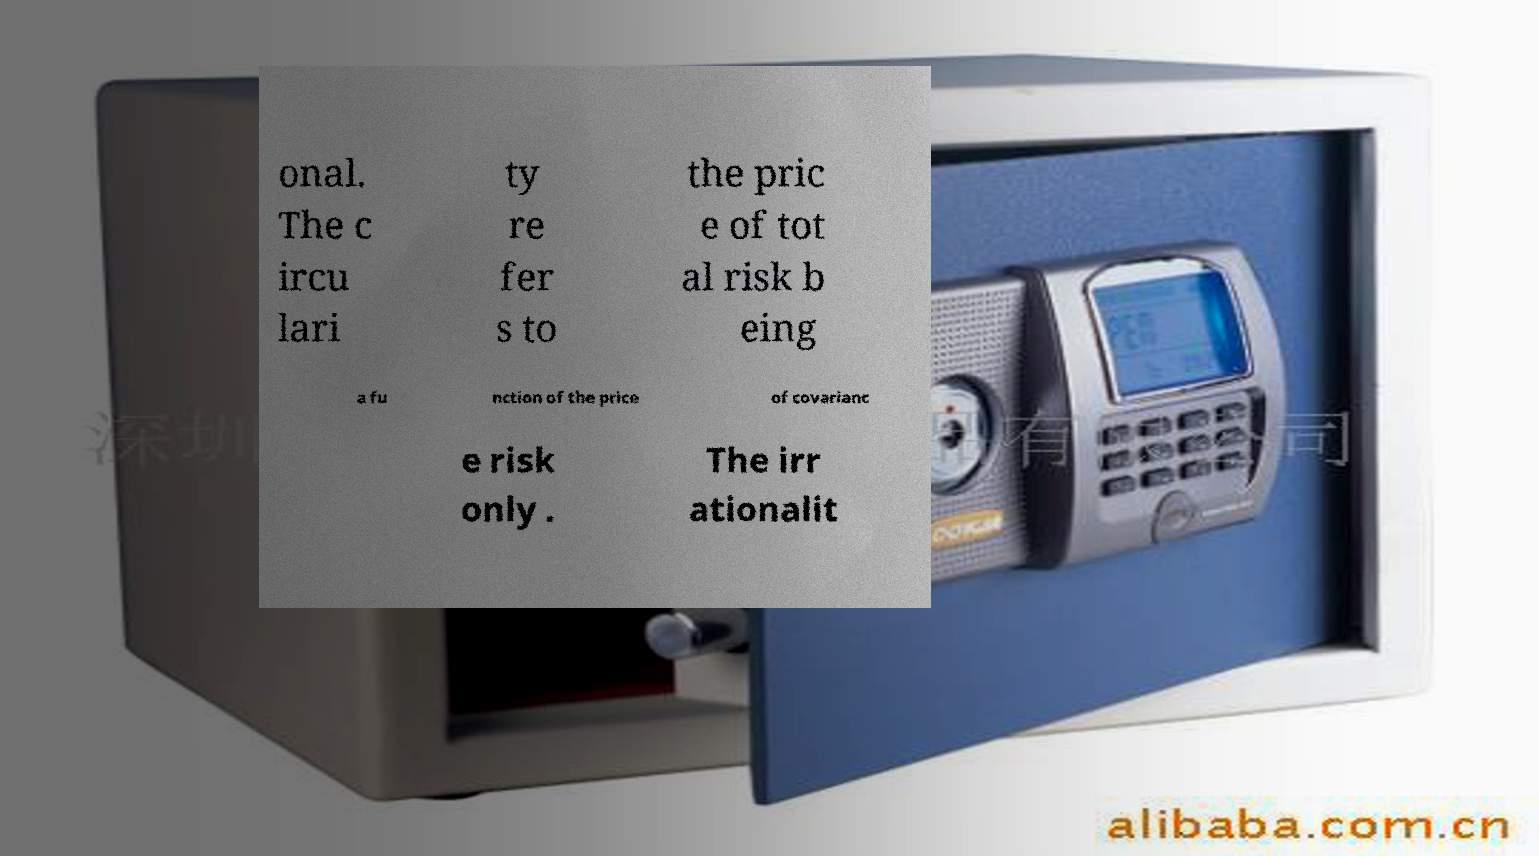Can you read and provide the text displayed in the image?This photo seems to have some interesting text. Can you extract and type it out for me? onal. The c ircu lari ty re fer s to the pric e of tot al risk b eing a fu nction of the price of covarianc e risk only . The irr ationalit 